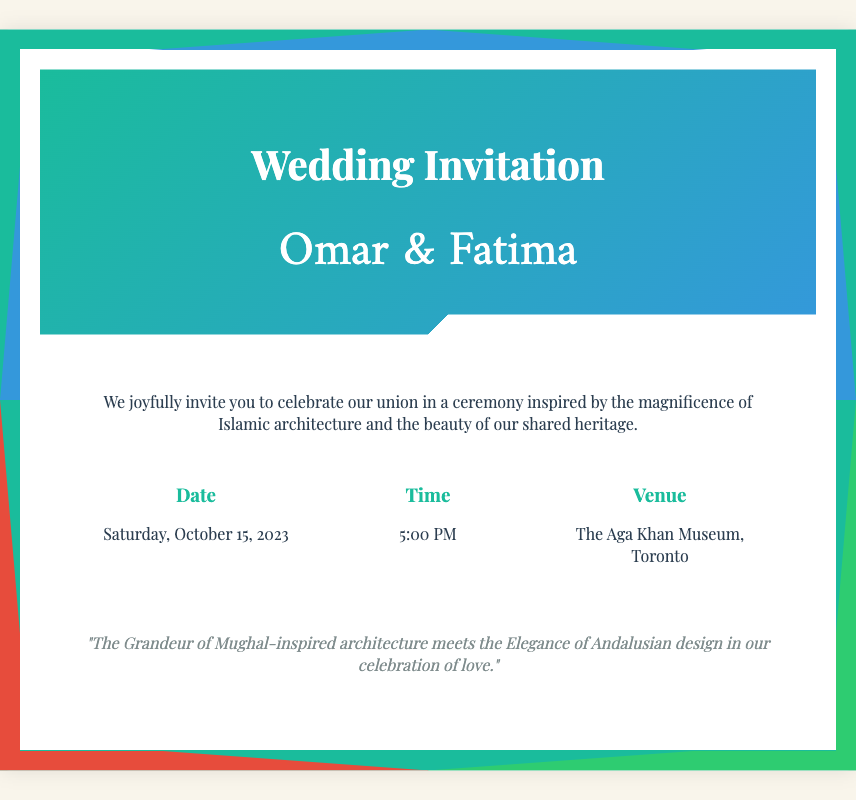What are the names of the couple? The names of the couple are clearly mentioned in the header of the invitation.
Answer: Omar & Fatima What is the date of the wedding? The date of the wedding is noted in the details section.
Answer: Saturday, October 15, 2023 What time does the wedding ceremony start? The starting time of the ceremony is provided under the time detail.
Answer: 5:00 PM Where is the wedding venue? The venue for the wedding is specified in the details section.
Answer: The Aga Khan Museum, Toronto What theme is the wedding inspired by? The theme of the wedding is described in the introductory paragraph.
Answer: Islamic architecture What is the significance of the quote in the invitation? The quote captures the essence of merging different architectural styles in their celebration.
Answer: The Grandeur of Mughal-inspired architecture meets the Elegance of Andalusian design in our celebration of love How is geometric design related to the invitation's aesthetics? The invitation incorporates geometric patterns as a visual motif, reflecting Islamic art.
Answer: Geometric designs are used as a border What cultural elements are mentioned regarding the wedding's inspiration? The invitation references specific cultural styles that influence the wedding.
Answer: Mughal and Andalusian designs What language styles are used in the names section? The names section employs different fonts to enhance aesthetic appeal.
Answer: Amiri and Playfair Display 